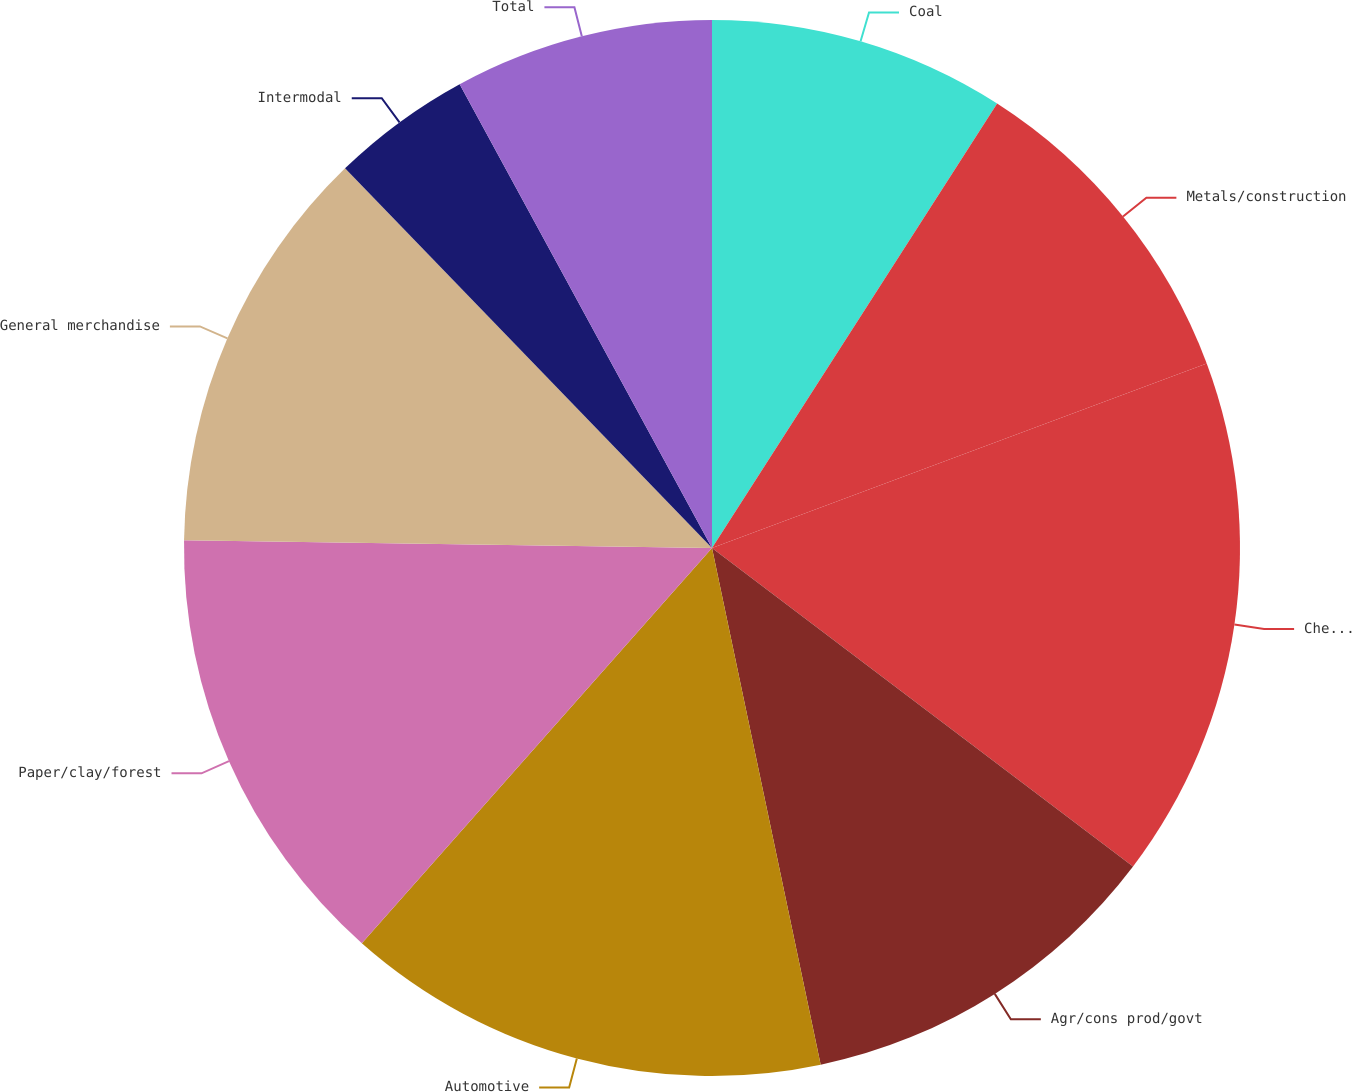Convert chart to OTSL. <chart><loc_0><loc_0><loc_500><loc_500><pie_chart><fcel>Coal<fcel>Metals/construction<fcel>Chemicals<fcel>Agr/cons prod/govt<fcel>Automotive<fcel>Paper/clay/forest<fcel>General merchandise<fcel>Intermodal<fcel>Total<nl><fcel>9.08%<fcel>10.24%<fcel>15.99%<fcel>11.39%<fcel>14.84%<fcel>13.69%<fcel>12.54%<fcel>4.3%<fcel>7.93%<nl></chart> 